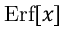<formula> <loc_0><loc_0><loc_500><loc_500>E r f [ x ]</formula> 